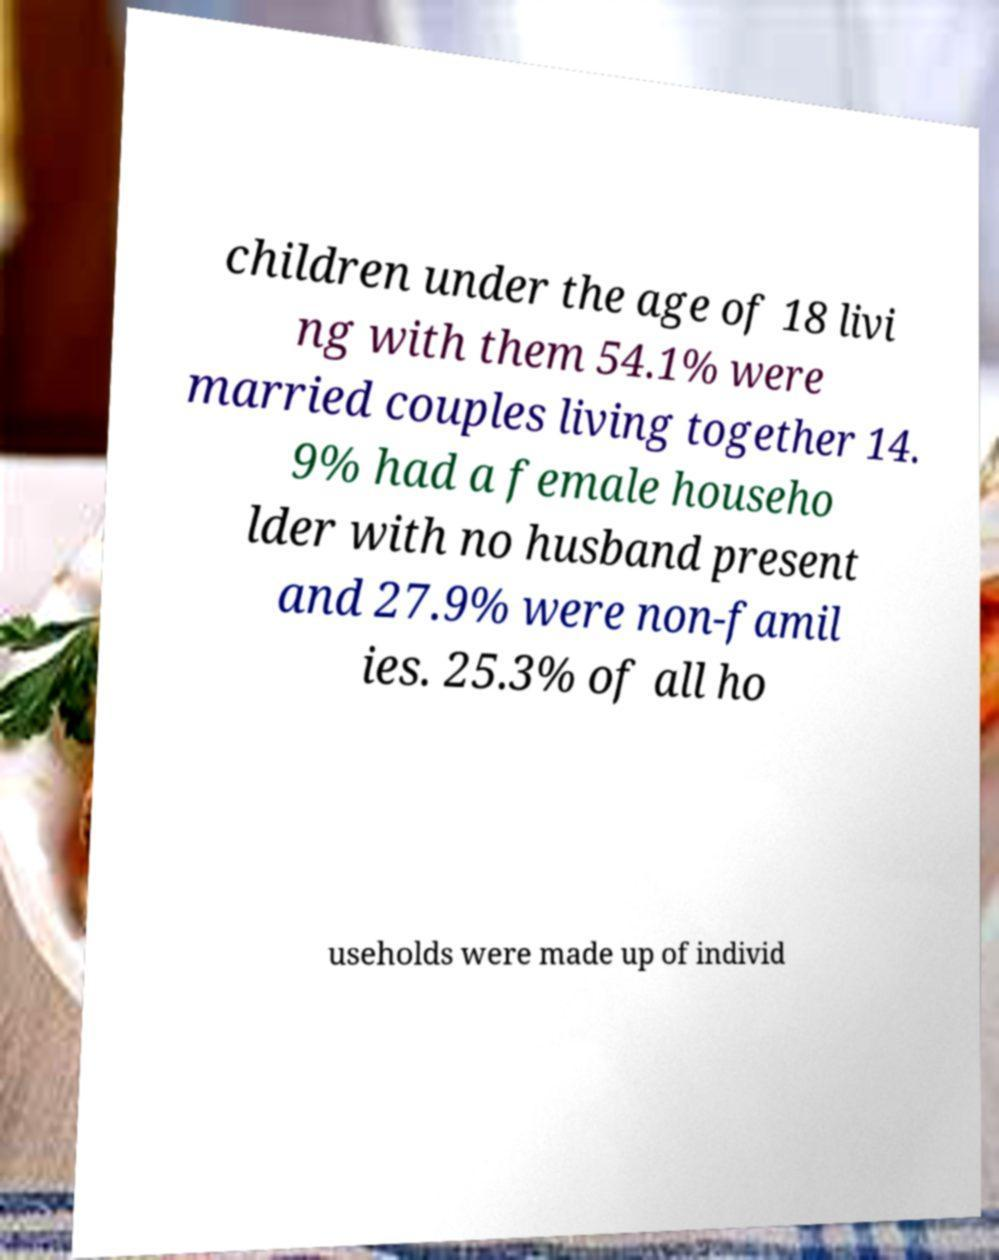Could you assist in decoding the text presented in this image and type it out clearly? children under the age of 18 livi ng with them 54.1% were married couples living together 14. 9% had a female househo lder with no husband present and 27.9% were non-famil ies. 25.3% of all ho useholds were made up of individ 